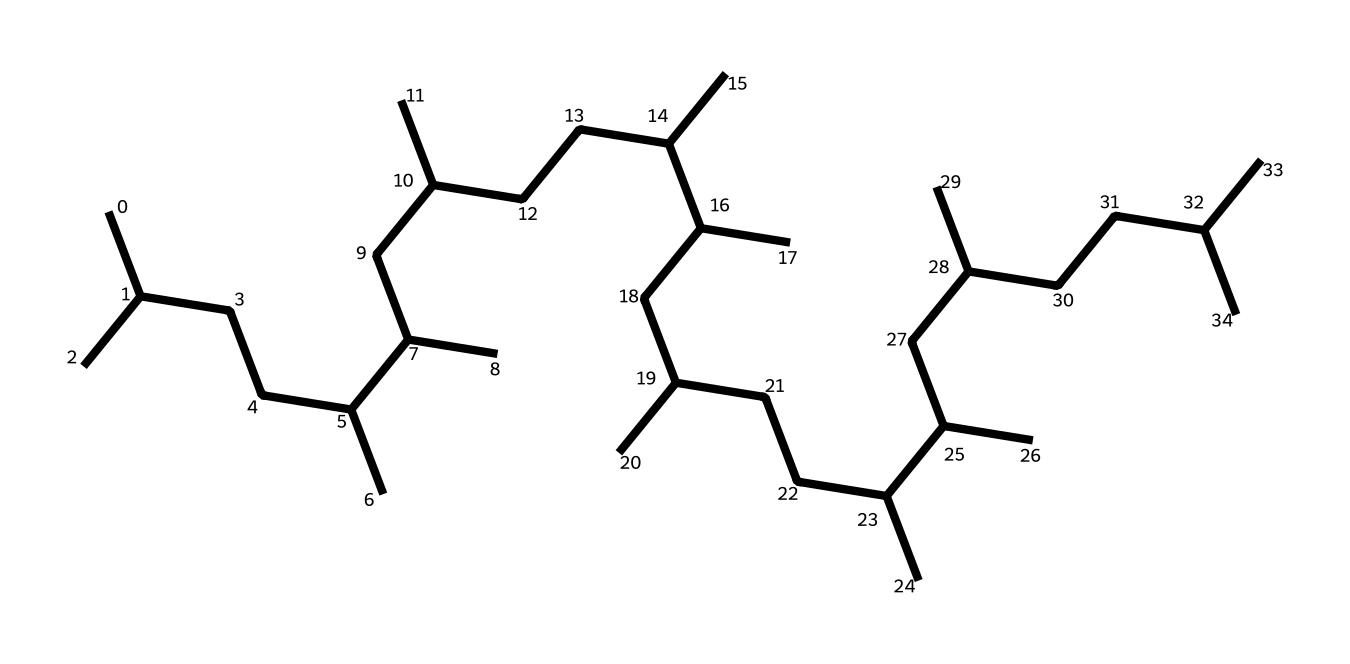What is the molecular formula of this compound? By counting the carbon (C) and hydrogen (H) atoms in the provided SMILES representation, we find that there are 30 carbon atoms and 62 hydrogen atoms. The molecular formula is derived from this counting.
Answer: C30H62 How many double bonds are present in this chemical structure? The SMILES representation shows only single bonds between carbon atoms and hydrogen atoms, indicating that this compound is saturated with no double bonds.
Answer: 0 What type of functional group is present in polyalphaolefin? Polyalphaolefin, as indicated by its structure, does not have any functional groups like -OH or -COOH; instead, it is purely a hydrocarbon, which signifies that it belongs to the alkane family.
Answer: alkane What does the branching in the molecule suggest about its properties? The presence of branched carbon chains in the structure of PAO suggests that it has lower viscosity at high temperatures compared to linear hydrocarbons, leading to enhanced lubricating properties.
Answer: lower viscosity What is the significance of the high degree of saturation in PAO? A high degree of saturation, as indicated by the absence of double bonds in the structure, contributes to the thermal stability and oxidative resistance of the synthetic lubricant, making it suitable for extreme conditions.
Answer: thermal stability How does the carbon chain length affect the lubrication properties? Longer carbon chains typically enhance the film strength and viscosity index of the lubricant, providing better performance under load and temperature fluctuations, as seen in the structure with multiple carbon atoms.
Answer: better performance 